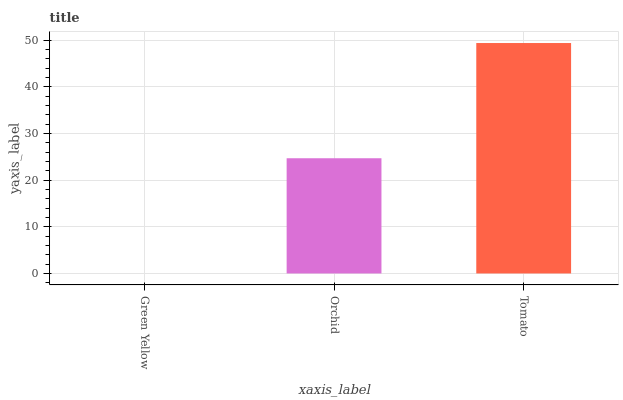Is Green Yellow the minimum?
Answer yes or no. Yes. Is Tomato the maximum?
Answer yes or no. Yes. Is Orchid the minimum?
Answer yes or no. No. Is Orchid the maximum?
Answer yes or no. No. Is Orchid greater than Green Yellow?
Answer yes or no. Yes. Is Green Yellow less than Orchid?
Answer yes or no. Yes. Is Green Yellow greater than Orchid?
Answer yes or no. No. Is Orchid less than Green Yellow?
Answer yes or no. No. Is Orchid the high median?
Answer yes or no. Yes. Is Orchid the low median?
Answer yes or no. Yes. Is Tomato the high median?
Answer yes or no. No. Is Tomato the low median?
Answer yes or no. No. 